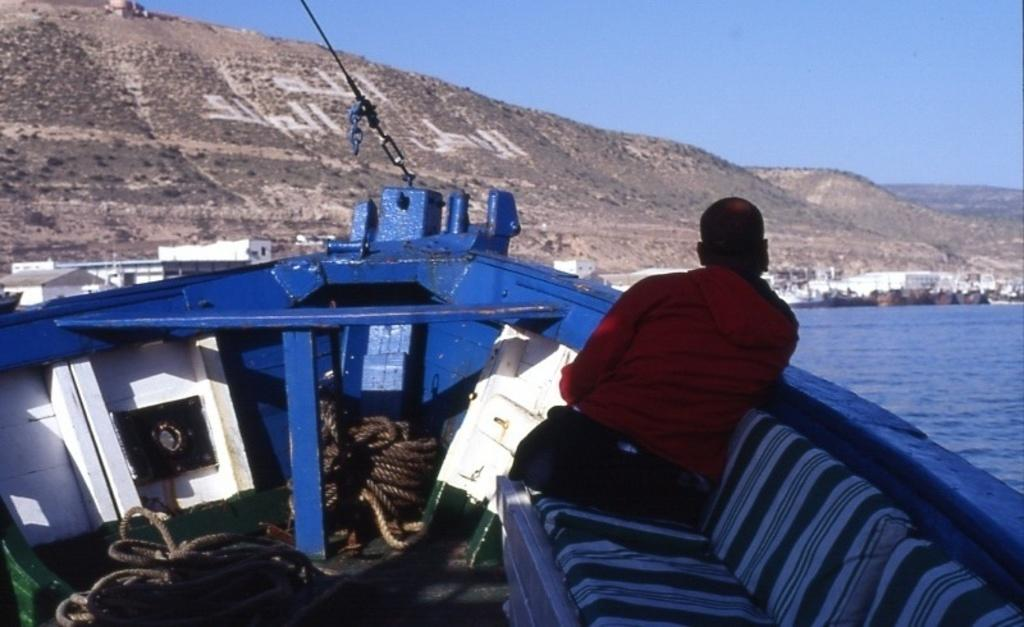What is the person in the image doing? There is a person sitting on a boat in the image. What is the primary setting of the image? There is water visible in the image. What can be seen in the distance in the image? There are mountains in the background of the image. What else is visible in the background of the image? The sky is visible in the background of the image. How many crates are visible on the boat in the image? There are no crates visible on the boat in the image. What type of bite can be seen on the person's arm in the image? There is no bite visible on the person's arm in the image. 